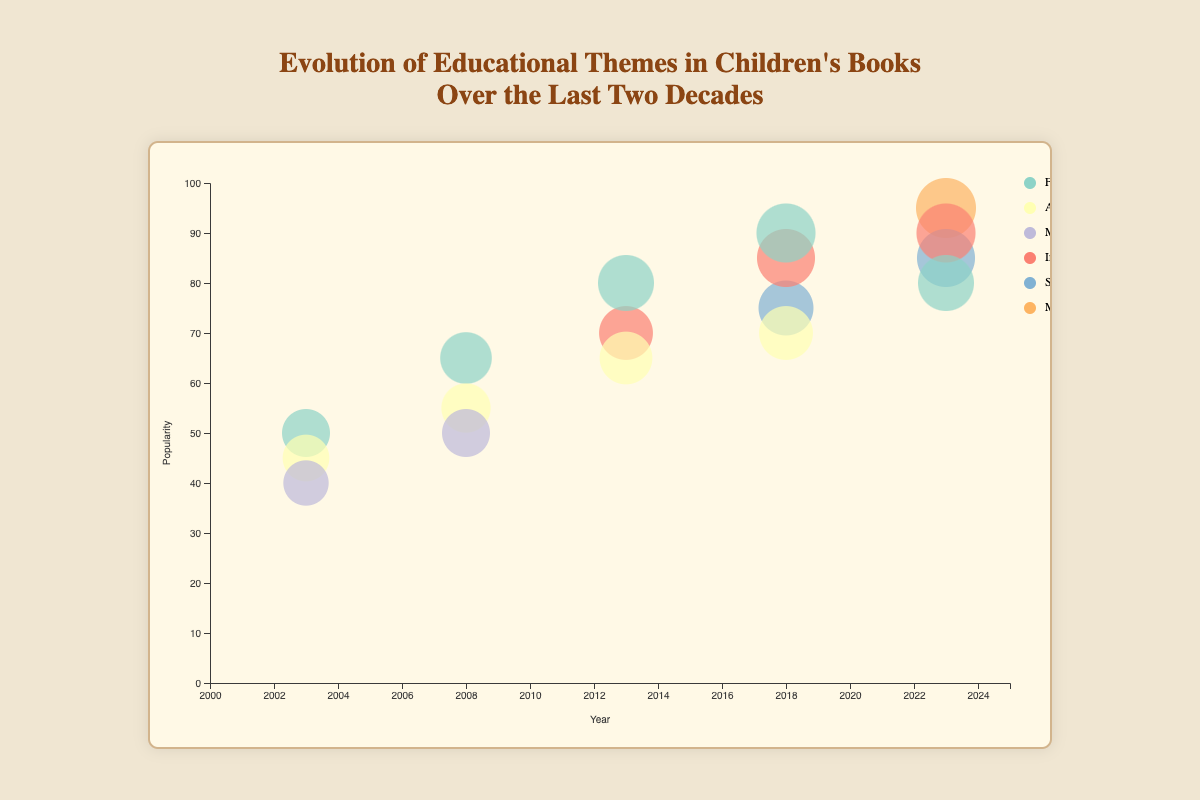What is the title of the chart? The title of the chart is typically displayed at the top of the chart and serves to summarize the key message or focus of the visualization. In this case, the title is "Evolution of Educational Themes in Children's Books Over the Last Two Decades."
Answer: Evolution of Educational Themes in Children's Books Over the Last Two Decades What theme had the highest popularity in 2023? To answer this question, look at the vertical position of the bubbles labeled with the year 2023. The highest bubble on the vertical axis in 2023 represents the theme with the highest popularity. The "Mental Health & Awareness" theme bubble is at the highest point.
Answer: Mental Health & Awareness How many unique themes are represented in the chart? Count the distinct themes listed in the legend, which shows a separate color for each theme. The themes listed are Friendship, Adventure, Moral Lessons, Inclusion & Diversity, STEM & Learning, and Mental Health & Awareness.
Answer: 6 Between which two consecutive years did the popularity of the "Friendship" theme increase the most? Compare the vertical position of the bubbles labeled with "Friendship" from year to year. The biggest vertical rise occurs between 2003 (50) and 2008 (65), which is an increase of 15 units.
Answer: 2003 and 2008 Which theme had the highest number of books published in 2018? To determine this, look at the size of the bubbles labeled for 2018. The largest bubble in 2018 is for the theme "Friendship," representing the highest number of books published.
Answer: Friendship What is the overall trend in popularity for the "Inclusion & Diversity" theme from 2013 to 2023? Trace the vertical positions of the "Inclusion & Diversity" bubbles over the years 2013, 2018, and 2023. These positions are 70 in 2013, 85 in 2018, and 90 in 2023, indicating a constant upward trend in popularity.
Answer: Increasing Which year had the theme with the highest number of books? Look for the largest bubble across all years, indicating the highest number of books. The largest bubble is in 2023 for the theme "Mental Health & Awareness" with 260 books.
Answer: 2023 What is the average popularity of the "STEM & Learning" theme for the years it appears? The "STEM & Learning" theme appears in 2018 and 2023 with popularity values of 75 and 85 respectively. The average is calculated as (75 + 85) / 2 = 80.
Answer: 80 Which theme had a popularity of 70 in 2018? Identify the bubble corresponding to a popularity value of 70 in the year 2018 by looking at the vertical position labeled 70 along the Y-axis. The theme with this popularity is "Adventure."
Answer: Adventure How did the number of books for the theme "Adventure" change from 2003 to 2023? Compare the size of the bubbles labeled "Adventure" in 2003 and 2023. In 2003, the number of books is 140, and in 2023, it is not listed, suggesting no entries. For complete analysis, only available data points are compared, likely reflecting a drop or change to other years.
Answer: Decreased 